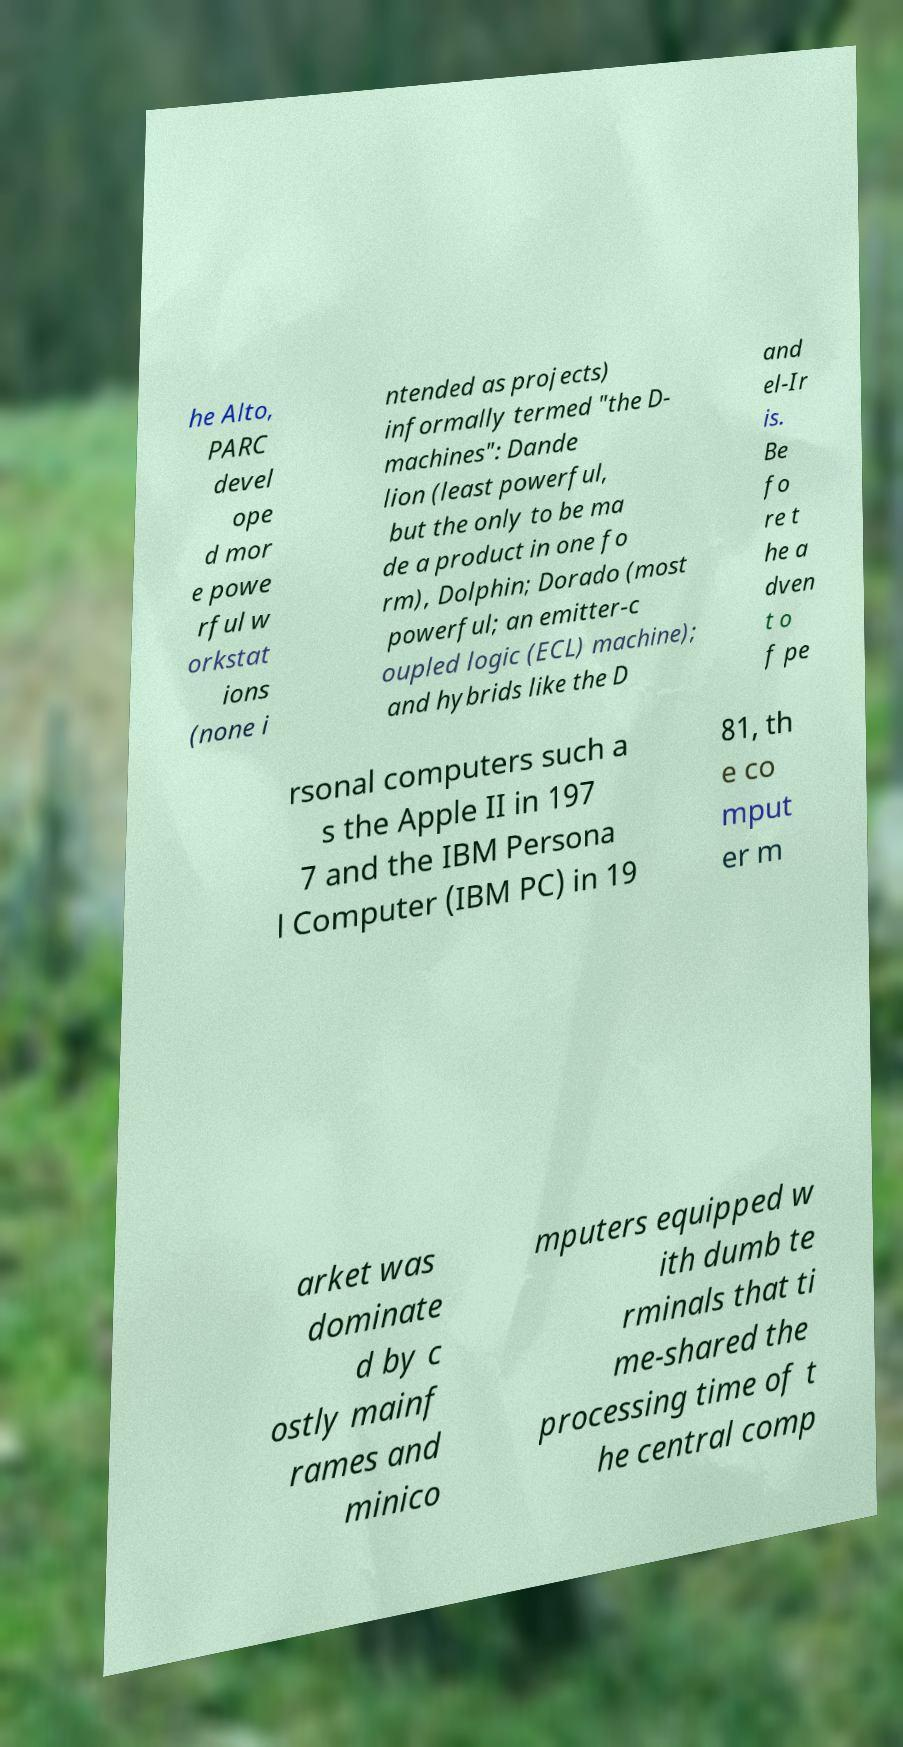What messages or text are displayed in this image? I need them in a readable, typed format. he Alto, PARC devel ope d mor e powe rful w orkstat ions (none i ntended as projects) informally termed "the D- machines": Dande lion (least powerful, but the only to be ma de a product in one fo rm), Dolphin; Dorado (most powerful; an emitter-c oupled logic (ECL) machine); and hybrids like the D and el-Ir is. Be fo re t he a dven t o f pe rsonal computers such a s the Apple II in 197 7 and the IBM Persona l Computer (IBM PC) in 19 81, th e co mput er m arket was dominate d by c ostly mainf rames and minico mputers equipped w ith dumb te rminals that ti me-shared the processing time of t he central comp 